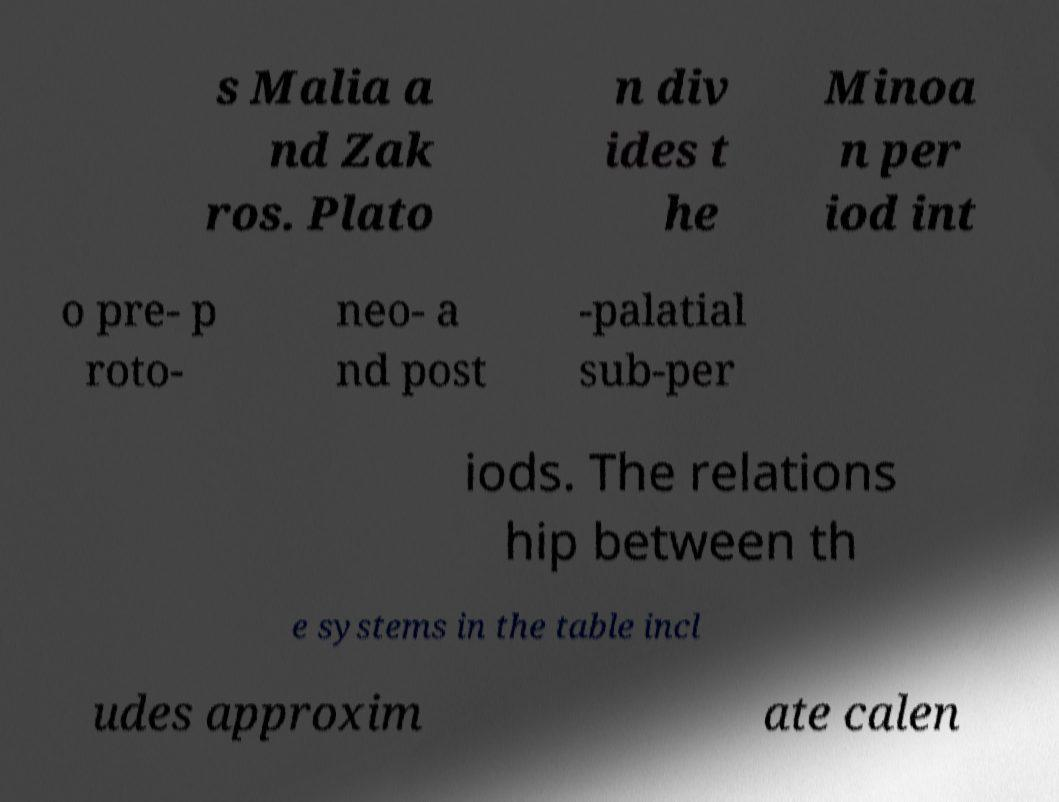Could you assist in decoding the text presented in this image and type it out clearly? s Malia a nd Zak ros. Plato n div ides t he Minoa n per iod int o pre- p roto- neo- a nd post -palatial sub-per iods. The relations hip between th e systems in the table incl udes approxim ate calen 